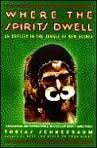What type of book is this? This is a travel book, detailing the author's personal experiences and adventures in the lush, uncharted territories of New Guinea. 